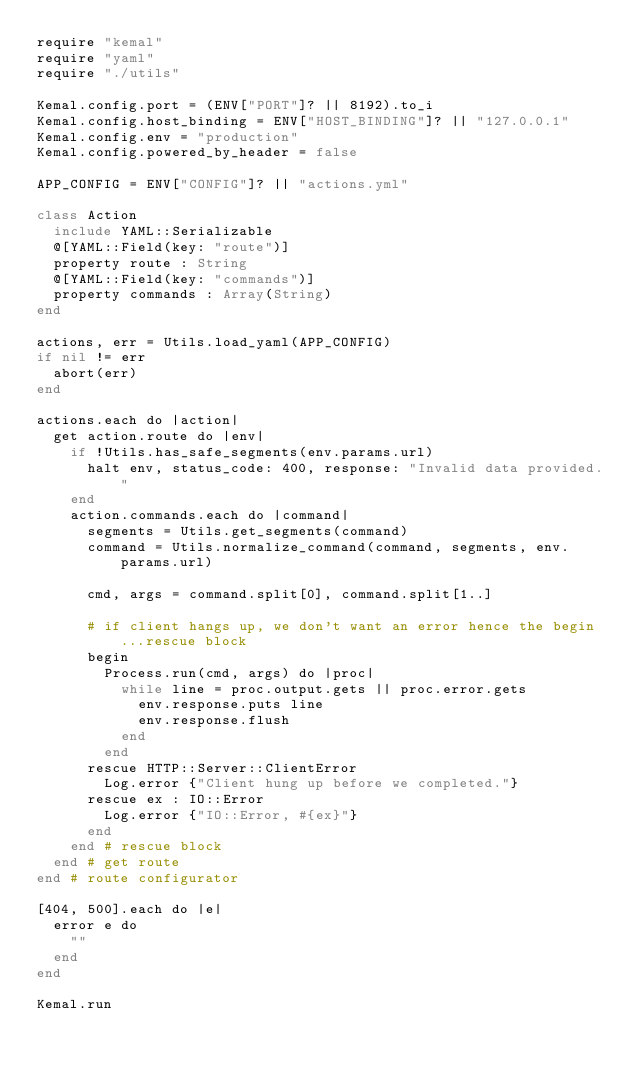<code> <loc_0><loc_0><loc_500><loc_500><_Crystal_>require "kemal"
require "yaml"
require "./utils"

Kemal.config.port = (ENV["PORT"]? || 8192).to_i
Kemal.config.host_binding = ENV["HOST_BINDING"]? || "127.0.0.1"
Kemal.config.env = "production"
Kemal.config.powered_by_header = false

APP_CONFIG = ENV["CONFIG"]? || "actions.yml"

class Action
  include YAML::Serializable
  @[YAML::Field(key: "route")]
  property route : String
  @[YAML::Field(key: "commands")]
  property commands : Array(String)
end

actions, err = Utils.load_yaml(APP_CONFIG)
if nil != err
  abort(err)
end

actions.each do |action|
  get action.route do |env|
    if !Utils.has_safe_segments(env.params.url)
      halt env, status_code: 400, response: "Invalid data provided."
    end
    action.commands.each do |command|
      segments = Utils.get_segments(command)
      command = Utils.normalize_command(command, segments, env.params.url)

      cmd, args = command.split[0], command.split[1..]

      # if client hangs up, we don't want an error hence the begin...rescue block
      begin
        Process.run(cmd, args) do |proc|
          while line = proc.output.gets || proc.error.gets
            env.response.puts line
            env.response.flush
          end
        end
      rescue HTTP::Server::ClientError
        Log.error {"Client hung up before we completed."}
      rescue ex : IO::Error
        Log.error {"IO::Error, #{ex}"}
      end
    end # rescue block
  end # get route
end # route configurator

[404, 500].each do |e|
  error e do
    ""
  end
end

Kemal.run
</code> 